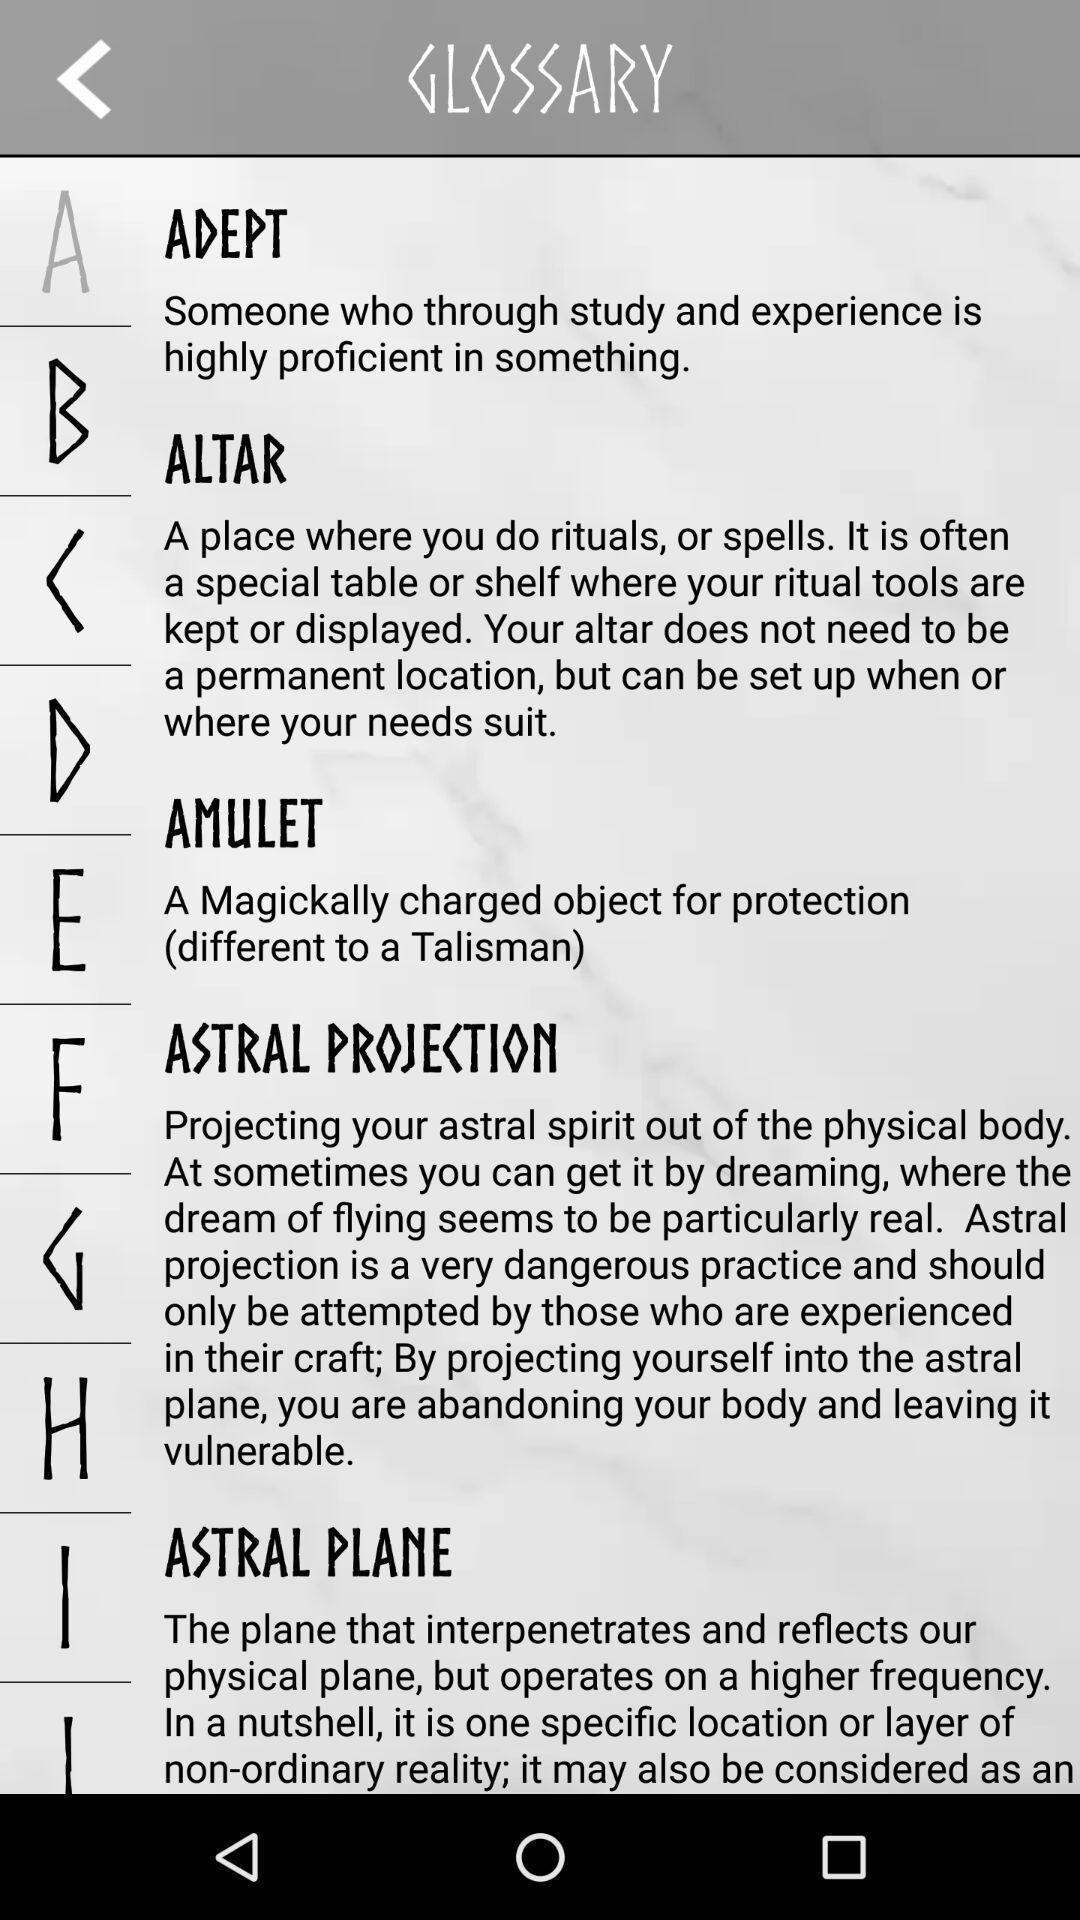Explain what's happening in this screen capture. Screen displaying multiple words and their meanings in alphabetical order. 